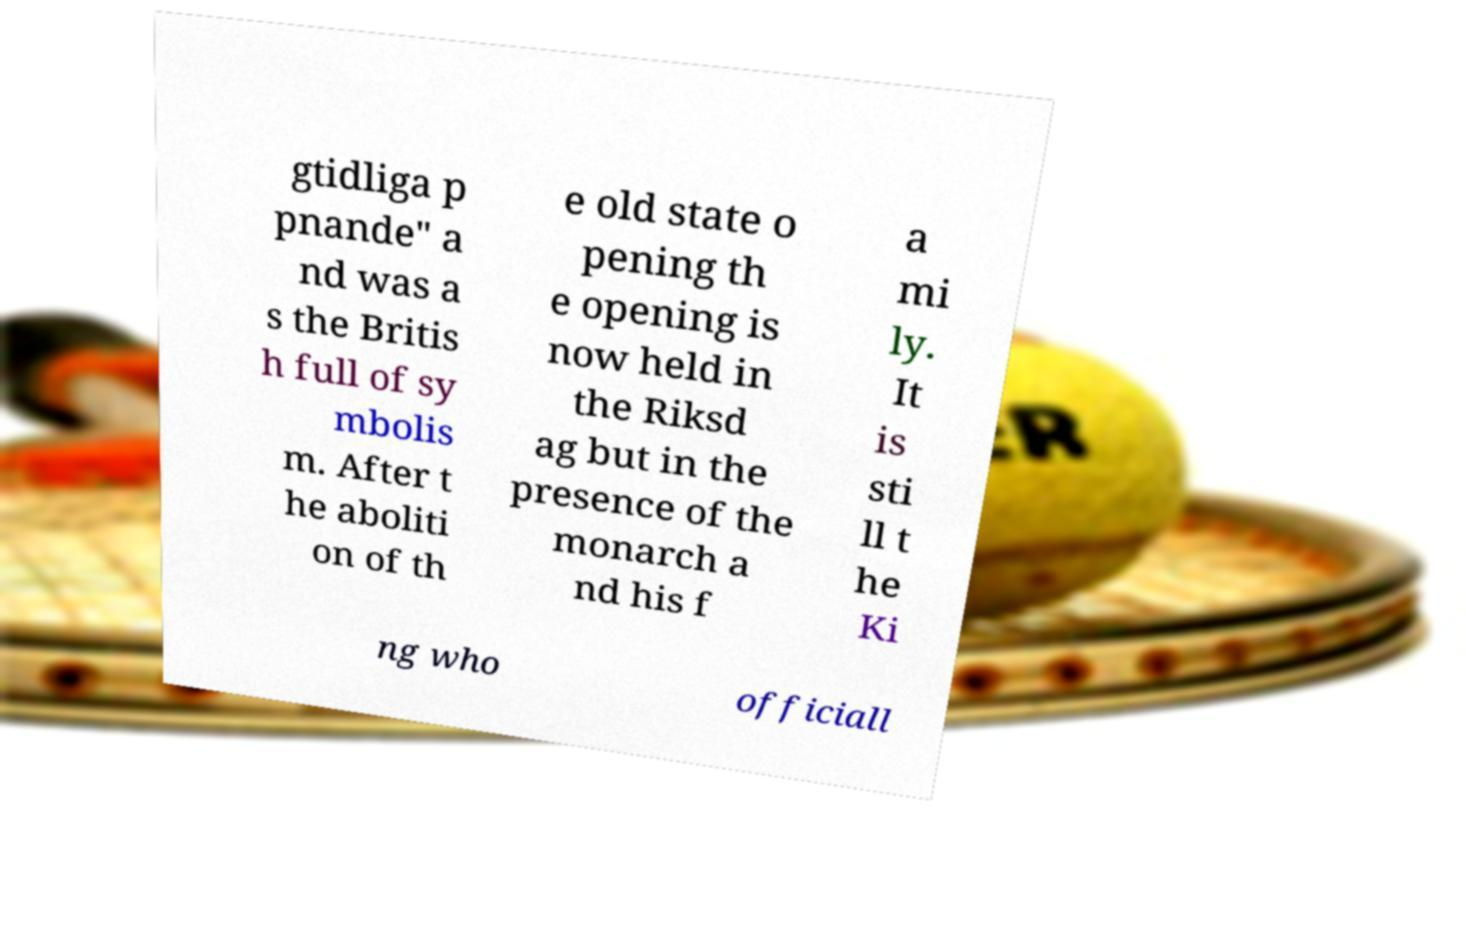Can you accurately transcribe the text from the provided image for me? gtidliga p pnande" a nd was a s the Britis h full of sy mbolis m. After t he aboliti on of th e old state o pening th e opening is now held in the Riksd ag but in the presence of the monarch a nd his f a mi ly. It is sti ll t he Ki ng who officiall 